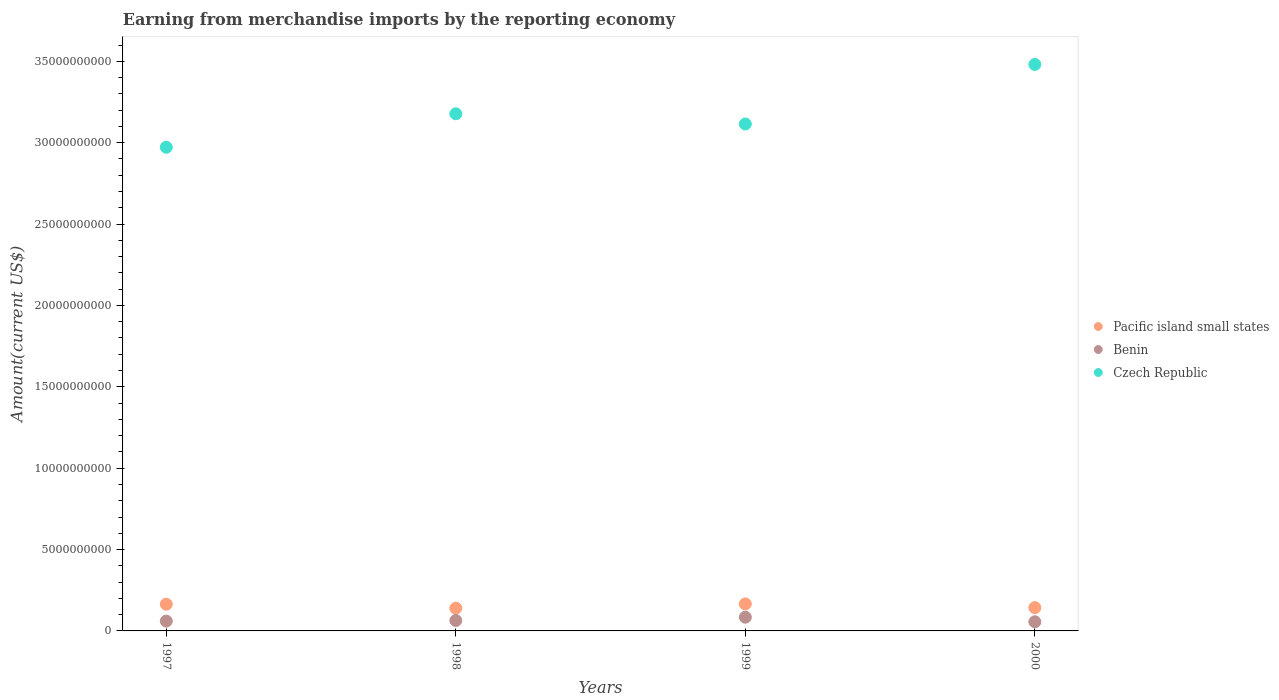How many different coloured dotlines are there?
Your answer should be compact. 3. Is the number of dotlines equal to the number of legend labels?
Provide a short and direct response. Yes. What is the amount earned from merchandise imports in Pacific island small states in 1998?
Ensure brevity in your answer.  1.40e+09. Across all years, what is the maximum amount earned from merchandise imports in Benin?
Make the answer very short. 8.43e+08. Across all years, what is the minimum amount earned from merchandise imports in Pacific island small states?
Your answer should be very brief. 1.40e+09. In which year was the amount earned from merchandise imports in Pacific island small states maximum?
Make the answer very short. 1999. In which year was the amount earned from merchandise imports in Czech Republic minimum?
Offer a very short reply. 1997. What is the total amount earned from merchandise imports in Benin in the graph?
Offer a terse response. 2.65e+09. What is the difference between the amount earned from merchandise imports in Benin in 1997 and that in 1998?
Ensure brevity in your answer.  -3.67e+07. What is the difference between the amount earned from merchandise imports in Benin in 1998 and the amount earned from merchandise imports in Czech Republic in 2000?
Your answer should be very brief. -3.42e+1. What is the average amount earned from merchandise imports in Pacific island small states per year?
Your response must be concise. 1.53e+09. In the year 1998, what is the difference between the amount earned from merchandise imports in Pacific island small states and amount earned from merchandise imports in Czech Republic?
Your answer should be compact. -3.04e+1. In how many years, is the amount earned from merchandise imports in Czech Republic greater than 3000000000 US$?
Provide a short and direct response. 4. What is the ratio of the amount earned from merchandise imports in Pacific island small states in 1997 to that in 2000?
Make the answer very short. 1.15. Is the amount earned from merchandise imports in Benin in 1997 less than that in 1999?
Provide a short and direct response. Yes. Is the difference between the amount earned from merchandise imports in Pacific island small states in 1998 and 2000 greater than the difference between the amount earned from merchandise imports in Czech Republic in 1998 and 2000?
Ensure brevity in your answer.  Yes. What is the difference between the highest and the second highest amount earned from merchandise imports in Pacific island small states?
Your answer should be compact. 2.10e+07. What is the difference between the highest and the lowest amount earned from merchandise imports in Czech Republic?
Offer a terse response. 5.09e+09. In how many years, is the amount earned from merchandise imports in Czech Republic greater than the average amount earned from merchandise imports in Czech Republic taken over all years?
Ensure brevity in your answer.  1. Does the amount earned from merchandise imports in Czech Republic monotonically increase over the years?
Ensure brevity in your answer.  No. Is the amount earned from merchandise imports in Pacific island small states strictly greater than the amount earned from merchandise imports in Czech Republic over the years?
Provide a succinct answer. No. Is the amount earned from merchandise imports in Benin strictly less than the amount earned from merchandise imports in Pacific island small states over the years?
Give a very brief answer. Yes. How many years are there in the graph?
Ensure brevity in your answer.  4. Does the graph contain grids?
Your answer should be very brief. No. What is the title of the graph?
Provide a short and direct response. Earning from merchandise imports by the reporting economy. Does "Turkey" appear as one of the legend labels in the graph?
Your answer should be compact. No. What is the label or title of the Y-axis?
Your answer should be compact. Amount(current US$). What is the Amount(current US$) in Pacific island small states in 1997?
Ensure brevity in your answer.  1.64e+09. What is the Amount(current US$) of Benin in 1997?
Give a very brief answer. 6.03e+08. What is the Amount(current US$) in Czech Republic in 1997?
Keep it short and to the point. 2.97e+1. What is the Amount(current US$) of Pacific island small states in 1998?
Your response must be concise. 1.40e+09. What is the Amount(current US$) in Benin in 1998?
Make the answer very short. 6.40e+08. What is the Amount(current US$) of Czech Republic in 1998?
Give a very brief answer. 3.18e+1. What is the Amount(current US$) in Pacific island small states in 1999?
Provide a succinct answer. 1.66e+09. What is the Amount(current US$) of Benin in 1999?
Offer a very short reply. 8.43e+08. What is the Amount(current US$) of Czech Republic in 1999?
Provide a succinct answer. 3.11e+1. What is the Amount(current US$) in Pacific island small states in 2000?
Your response must be concise. 1.43e+09. What is the Amount(current US$) in Benin in 2000?
Make the answer very short. 5.63e+08. What is the Amount(current US$) of Czech Republic in 2000?
Provide a short and direct response. 3.48e+1. Across all years, what is the maximum Amount(current US$) of Pacific island small states?
Provide a succinct answer. 1.66e+09. Across all years, what is the maximum Amount(current US$) in Benin?
Offer a very short reply. 8.43e+08. Across all years, what is the maximum Amount(current US$) of Czech Republic?
Your answer should be compact. 3.48e+1. Across all years, what is the minimum Amount(current US$) in Pacific island small states?
Give a very brief answer. 1.40e+09. Across all years, what is the minimum Amount(current US$) of Benin?
Make the answer very short. 5.63e+08. Across all years, what is the minimum Amount(current US$) in Czech Republic?
Make the answer very short. 2.97e+1. What is the total Amount(current US$) of Pacific island small states in the graph?
Make the answer very short. 6.13e+09. What is the total Amount(current US$) of Benin in the graph?
Keep it short and to the point. 2.65e+09. What is the total Amount(current US$) of Czech Republic in the graph?
Provide a succinct answer. 1.27e+11. What is the difference between the Amount(current US$) of Pacific island small states in 1997 and that in 1998?
Provide a succinct answer. 2.45e+08. What is the difference between the Amount(current US$) in Benin in 1997 and that in 1998?
Your answer should be very brief. -3.67e+07. What is the difference between the Amount(current US$) in Czech Republic in 1997 and that in 1998?
Offer a very short reply. -2.06e+09. What is the difference between the Amount(current US$) of Pacific island small states in 1997 and that in 1999?
Keep it short and to the point. -2.10e+07. What is the difference between the Amount(current US$) of Benin in 1997 and that in 1999?
Provide a short and direct response. -2.40e+08. What is the difference between the Amount(current US$) in Czech Republic in 1997 and that in 1999?
Provide a short and direct response. -1.43e+09. What is the difference between the Amount(current US$) in Pacific island small states in 1997 and that in 2000?
Provide a short and direct response. 2.10e+08. What is the difference between the Amount(current US$) of Benin in 1997 and that in 2000?
Keep it short and to the point. 4.02e+07. What is the difference between the Amount(current US$) of Czech Republic in 1997 and that in 2000?
Your response must be concise. -5.09e+09. What is the difference between the Amount(current US$) of Pacific island small states in 1998 and that in 1999?
Give a very brief answer. -2.66e+08. What is the difference between the Amount(current US$) in Benin in 1998 and that in 1999?
Make the answer very short. -2.04e+08. What is the difference between the Amount(current US$) in Czech Republic in 1998 and that in 1999?
Your answer should be very brief. 6.29e+08. What is the difference between the Amount(current US$) in Pacific island small states in 1998 and that in 2000?
Provide a succinct answer. -3.46e+07. What is the difference between the Amount(current US$) of Benin in 1998 and that in 2000?
Give a very brief answer. 7.68e+07. What is the difference between the Amount(current US$) of Czech Republic in 1998 and that in 2000?
Give a very brief answer. -3.03e+09. What is the difference between the Amount(current US$) in Pacific island small states in 1999 and that in 2000?
Make the answer very short. 2.31e+08. What is the difference between the Amount(current US$) in Benin in 1999 and that in 2000?
Provide a succinct answer. 2.81e+08. What is the difference between the Amount(current US$) of Czech Republic in 1999 and that in 2000?
Make the answer very short. -3.66e+09. What is the difference between the Amount(current US$) of Pacific island small states in 1997 and the Amount(current US$) of Benin in 1998?
Ensure brevity in your answer.  1.00e+09. What is the difference between the Amount(current US$) of Pacific island small states in 1997 and the Amount(current US$) of Czech Republic in 1998?
Your answer should be very brief. -3.01e+1. What is the difference between the Amount(current US$) of Benin in 1997 and the Amount(current US$) of Czech Republic in 1998?
Offer a very short reply. -3.12e+1. What is the difference between the Amount(current US$) in Pacific island small states in 1997 and the Amount(current US$) in Benin in 1999?
Ensure brevity in your answer.  7.98e+08. What is the difference between the Amount(current US$) of Pacific island small states in 1997 and the Amount(current US$) of Czech Republic in 1999?
Ensure brevity in your answer.  -2.95e+1. What is the difference between the Amount(current US$) of Benin in 1997 and the Amount(current US$) of Czech Republic in 1999?
Ensure brevity in your answer.  -3.05e+1. What is the difference between the Amount(current US$) in Pacific island small states in 1997 and the Amount(current US$) in Benin in 2000?
Ensure brevity in your answer.  1.08e+09. What is the difference between the Amount(current US$) of Pacific island small states in 1997 and the Amount(current US$) of Czech Republic in 2000?
Your response must be concise. -3.32e+1. What is the difference between the Amount(current US$) of Benin in 1997 and the Amount(current US$) of Czech Republic in 2000?
Provide a short and direct response. -3.42e+1. What is the difference between the Amount(current US$) of Pacific island small states in 1998 and the Amount(current US$) of Benin in 1999?
Keep it short and to the point. 5.53e+08. What is the difference between the Amount(current US$) of Pacific island small states in 1998 and the Amount(current US$) of Czech Republic in 1999?
Your answer should be compact. -2.98e+1. What is the difference between the Amount(current US$) of Benin in 1998 and the Amount(current US$) of Czech Republic in 1999?
Your answer should be compact. -3.05e+1. What is the difference between the Amount(current US$) of Pacific island small states in 1998 and the Amount(current US$) of Benin in 2000?
Give a very brief answer. 8.34e+08. What is the difference between the Amount(current US$) in Pacific island small states in 1998 and the Amount(current US$) in Czech Republic in 2000?
Your response must be concise. -3.34e+1. What is the difference between the Amount(current US$) in Benin in 1998 and the Amount(current US$) in Czech Republic in 2000?
Provide a short and direct response. -3.42e+1. What is the difference between the Amount(current US$) of Pacific island small states in 1999 and the Amount(current US$) of Benin in 2000?
Offer a terse response. 1.10e+09. What is the difference between the Amount(current US$) in Pacific island small states in 1999 and the Amount(current US$) in Czech Republic in 2000?
Ensure brevity in your answer.  -3.31e+1. What is the difference between the Amount(current US$) of Benin in 1999 and the Amount(current US$) of Czech Republic in 2000?
Offer a terse response. -3.40e+1. What is the average Amount(current US$) in Pacific island small states per year?
Your answer should be very brief. 1.53e+09. What is the average Amount(current US$) in Benin per year?
Provide a short and direct response. 6.62e+08. What is the average Amount(current US$) of Czech Republic per year?
Ensure brevity in your answer.  3.19e+1. In the year 1997, what is the difference between the Amount(current US$) of Pacific island small states and Amount(current US$) of Benin?
Make the answer very short. 1.04e+09. In the year 1997, what is the difference between the Amount(current US$) in Pacific island small states and Amount(current US$) in Czech Republic?
Give a very brief answer. -2.81e+1. In the year 1997, what is the difference between the Amount(current US$) of Benin and Amount(current US$) of Czech Republic?
Your response must be concise. -2.91e+1. In the year 1998, what is the difference between the Amount(current US$) in Pacific island small states and Amount(current US$) in Benin?
Give a very brief answer. 7.57e+08. In the year 1998, what is the difference between the Amount(current US$) in Pacific island small states and Amount(current US$) in Czech Republic?
Offer a very short reply. -3.04e+1. In the year 1998, what is the difference between the Amount(current US$) in Benin and Amount(current US$) in Czech Republic?
Your response must be concise. -3.11e+1. In the year 1999, what is the difference between the Amount(current US$) in Pacific island small states and Amount(current US$) in Benin?
Keep it short and to the point. 8.19e+08. In the year 1999, what is the difference between the Amount(current US$) in Pacific island small states and Amount(current US$) in Czech Republic?
Your answer should be compact. -2.95e+1. In the year 1999, what is the difference between the Amount(current US$) of Benin and Amount(current US$) of Czech Republic?
Offer a very short reply. -3.03e+1. In the year 2000, what is the difference between the Amount(current US$) in Pacific island small states and Amount(current US$) in Benin?
Offer a terse response. 8.68e+08. In the year 2000, what is the difference between the Amount(current US$) of Pacific island small states and Amount(current US$) of Czech Republic?
Your response must be concise. -3.34e+1. In the year 2000, what is the difference between the Amount(current US$) in Benin and Amount(current US$) in Czech Republic?
Keep it short and to the point. -3.42e+1. What is the ratio of the Amount(current US$) of Pacific island small states in 1997 to that in 1998?
Your answer should be compact. 1.18. What is the ratio of the Amount(current US$) in Benin in 1997 to that in 1998?
Provide a short and direct response. 0.94. What is the ratio of the Amount(current US$) in Czech Republic in 1997 to that in 1998?
Your response must be concise. 0.94. What is the ratio of the Amount(current US$) of Pacific island small states in 1997 to that in 1999?
Provide a short and direct response. 0.99. What is the ratio of the Amount(current US$) in Benin in 1997 to that in 1999?
Make the answer very short. 0.71. What is the ratio of the Amount(current US$) in Czech Republic in 1997 to that in 1999?
Give a very brief answer. 0.95. What is the ratio of the Amount(current US$) in Pacific island small states in 1997 to that in 2000?
Ensure brevity in your answer.  1.15. What is the ratio of the Amount(current US$) of Benin in 1997 to that in 2000?
Your answer should be very brief. 1.07. What is the ratio of the Amount(current US$) of Czech Republic in 1997 to that in 2000?
Your response must be concise. 0.85. What is the ratio of the Amount(current US$) of Pacific island small states in 1998 to that in 1999?
Offer a very short reply. 0.84. What is the ratio of the Amount(current US$) of Benin in 1998 to that in 1999?
Give a very brief answer. 0.76. What is the ratio of the Amount(current US$) of Czech Republic in 1998 to that in 1999?
Provide a succinct answer. 1.02. What is the ratio of the Amount(current US$) of Pacific island small states in 1998 to that in 2000?
Make the answer very short. 0.98. What is the ratio of the Amount(current US$) of Benin in 1998 to that in 2000?
Provide a succinct answer. 1.14. What is the ratio of the Amount(current US$) of Czech Republic in 1998 to that in 2000?
Offer a very short reply. 0.91. What is the ratio of the Amount(current US$) in Pacific island small states in 1999 to that in 2000?
Offer a terse response. 1.16. What is the ratio of the Amount(current US$) in Benin in 1999 to that in 2000?
Provide a short and direct response. 1.5. What is the ratio of the Amount(current US$) of Czech Republic in 1999 to that in 2000?
Offer a terse response. 0.89. What is the difference between the highest and the second highest Amount(current US$) of Pacific island small states?
Your answer should be compact. 2.10e+07. What is the difference between the highest and the second highest Amount(current US$) of Benin?
Offer a terse response. 2.04e+08. What is the difference between the highest and the second highest Amount(current US$) in Czech Republic?
Provide a short and direct response. 3.03e+09. What is the difference between the highest and the lowest Amount(current US$) in Pacific island small states?
Provide a short and direct response. 2.66e+08. What is the difference between the highest and the lowest Amount(current US$) of Benin?
Provide a short and direct response. 2.81e+08. What is the difference between the highest and the lowest Amount(current US$) in Czech Republic?
Your answer should be compact. 5.09e+09. 